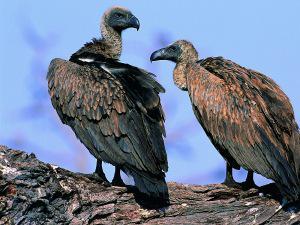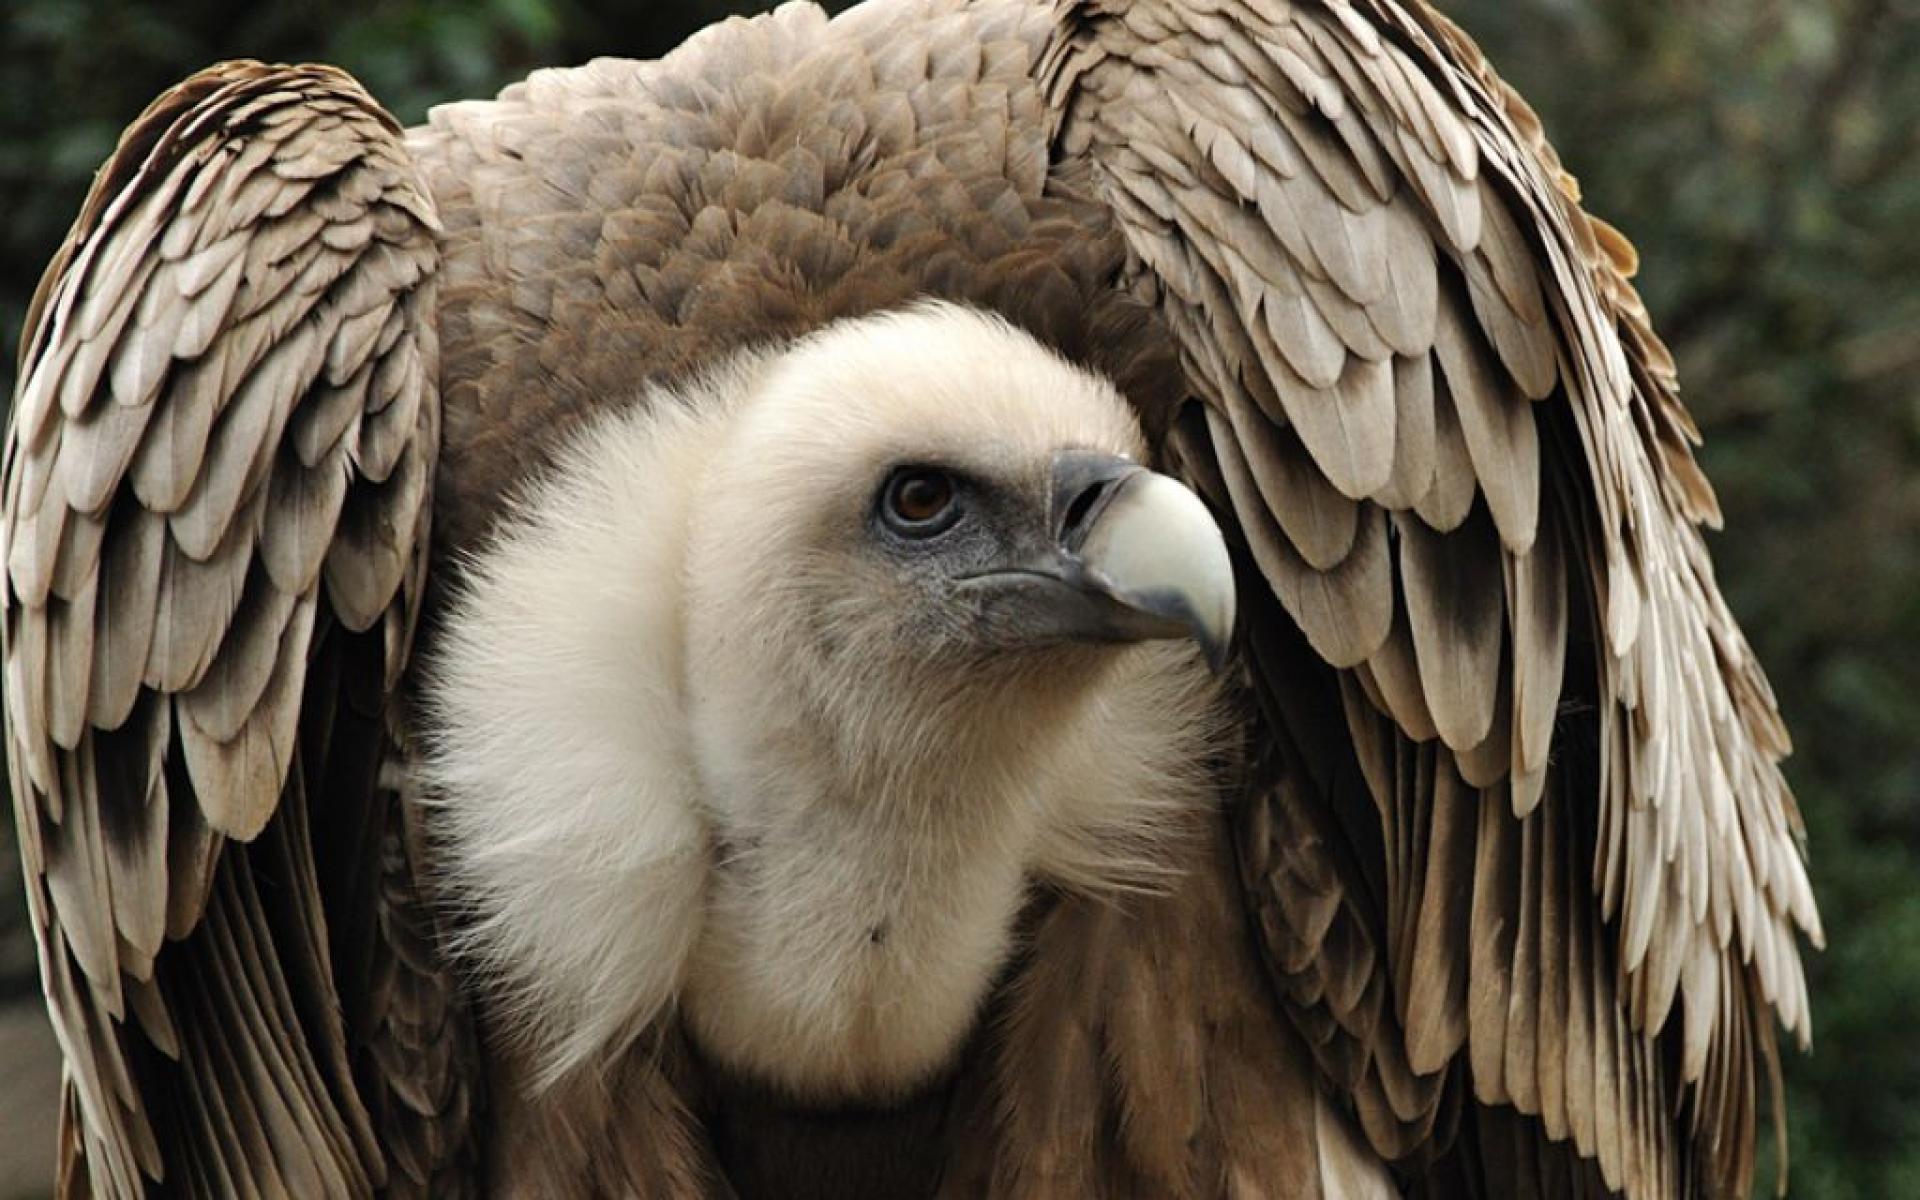The first image is the image on the left, the second image is the image on the right. For the images shown, is this caption "An image shows exactly two vultures with sky-blue background." true? Answer yes or no. Yes. The first image is the image on the left, the second image is the image on the right. Assess this claim about the two images: "One of the images shows exactly two birds.". Correct or not? Answer yes or no. Yes. 